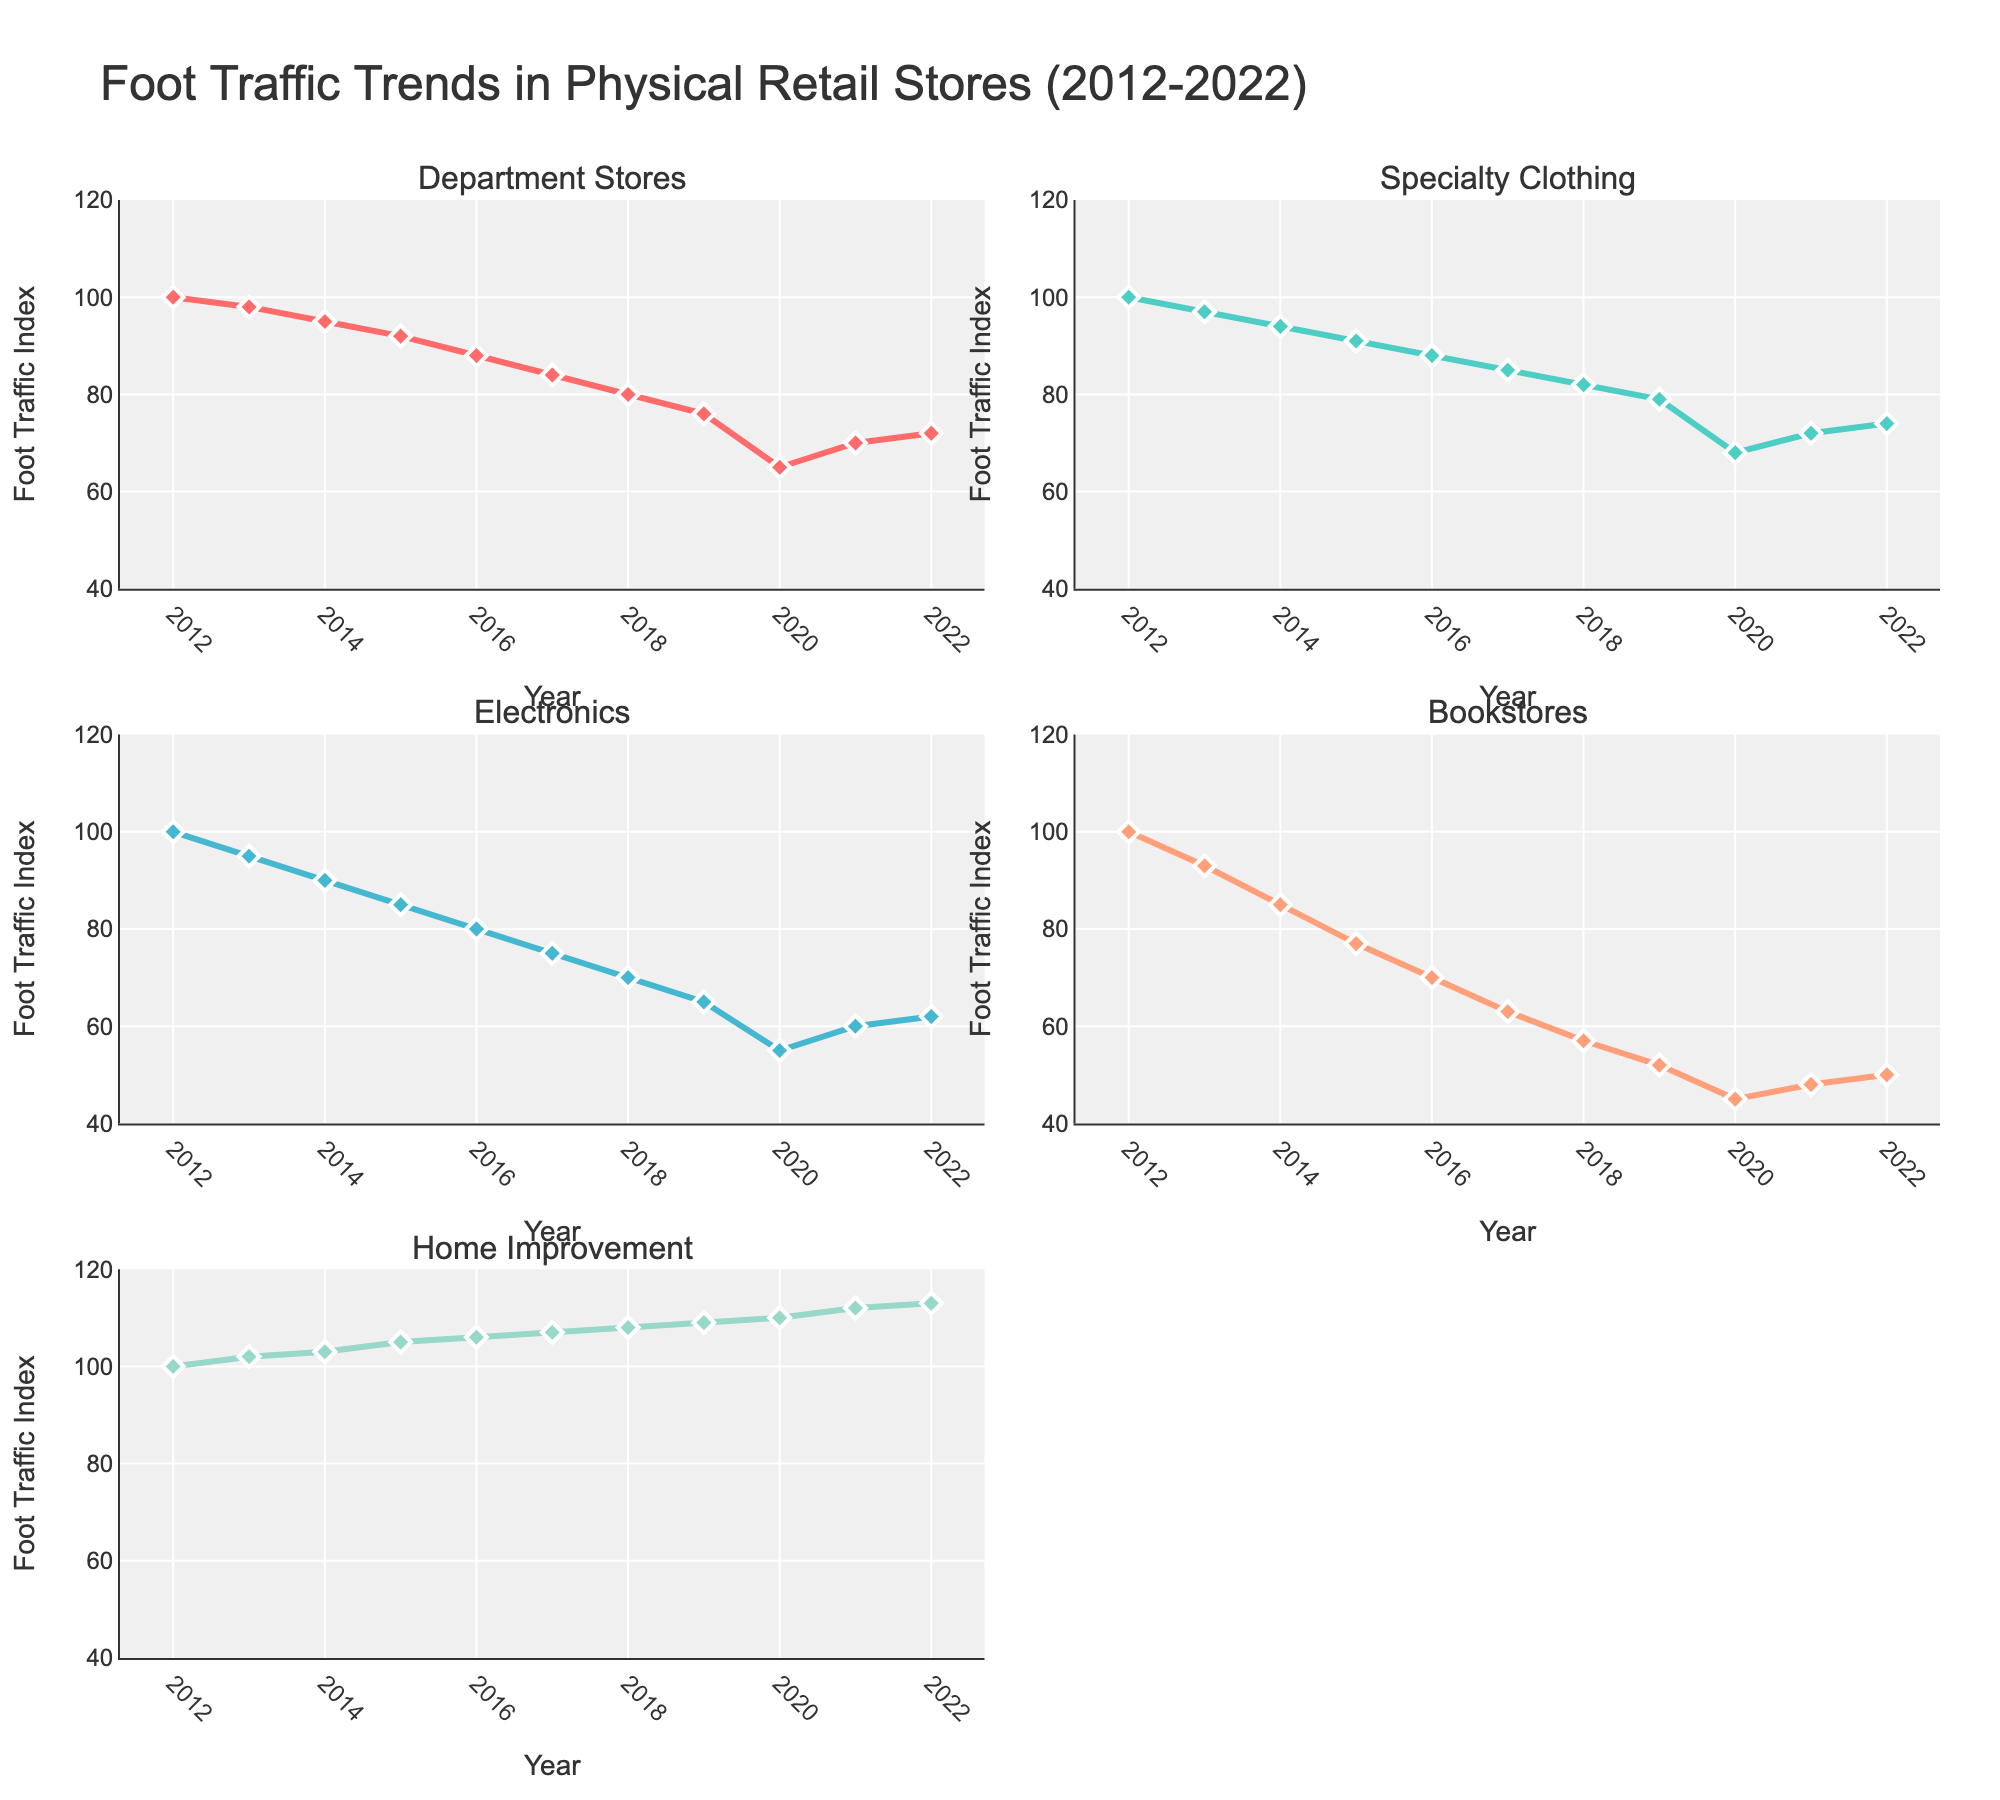How many store types are compared in the figure? The subplot titles list five different store types. Each subplot represents a unique store type.
Answer: Five Which store type has the highest foot traffic index in 2022? The subplot for 'Home Improvement' shows the foot traffic index value of 113 in 2022, which is higher than the values in other store types.
Answer: Home Improvement Which store type experienced the largest decrease in foot traffic from 2012 to 2018? Comparing the lines from 2012 to 2018, 'Bookstores' shows a drop from 100 to 57, which is the largest reduction.
Answer: Bookstores In which year do 'Electronics' stores dip to a foot traffic index of 55? In the subplot for 'Electronics', the line corresponding to 2020 shows a foot traffic index of 55.
Answer: 2020 What trend can be observed for foot traffic in 'Home Improvement' stores over the decade? The line in the 'Home Improvement' subplot shows a consistent increase from 100 in 2012 to 113 in 2022.
Answer: Increasing Between 2013 and 2014, which store type shows the greatest drop in foot traffic? Comparing the vertical drops between these years, 'Bookstores' has the most significant decrease from 93 to 85.
Answer: Bookstores By how much did the foot traffic index for 'Department Stores' change from 2012 to 2022? The 'Department Stores' subplot indicates a decrease from 100 in 2012 to 72 in 2022. So, the change is 100 - 72.
Answer: 28 What common trend is observed across all types of stores from 2012 to 2019? All subplots show a downward trend in foot traffic from 2012 to 2019, indicated by the decreasing lines.
Answer: Decreasing Which store type shows a recovery in foot traffic index after 2020? Both 'Department Stores' and 'Specialty Clothing' show an increase in foot traffic index post-2020 as indicated by upward trending lines in their respective subplots.
Answer: Department Stores, Specialty Clothing 